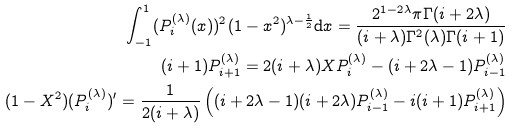Convert formula to latex. <formula><loc_0><loc_0><loc_500><loc_500>\int _ { - 1 } ^ { 1 } ( P _ { i } ^ { ( \lambda ) } ( x ) ) ^ { 2 } ( 1 - x ^ { 2 } ) ^ { \lambda - \frac { 1 } { 2 } } \mathrm d x = \frac { 2 ^ { 1 - 2 \lambda } \pi \Gamma ( i + 2 \lambda ) } { ( i + \lambda ) \Gamma ^ { 2 } ( \lambda ) \Gamma ( i + 1 ) } \\ ( i + 1 ) P _ { i + 1 } ^ { ( \lambda ) } = 2 ( i + \lambda ) X P _ { i } ^ { ( \lambda ) } - ( i + 2 \lambda - 1 ) P _ { i - 1 } ^ { ( \lambda ) } \\ ( 1 - X ^ { 2 } ) ( P _ { i } ^ { ( \lambda ) } ) ^ { \prime } = \frac { 1 } { 2 ( i + \lambda ) } \left ( ( i + 2 \lambda - 1 ) ( i + 2 \lambda ) P _ { i - 1 } ^ { ( \lambda ) } - i ( i + 1 ) P _ { i + 1 } ^ { ( \lambda ) } \right )</formula> 